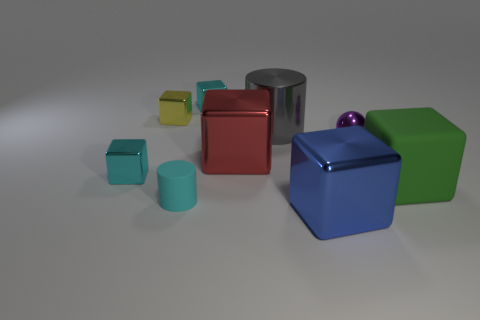How many cyan cubes are to the left of the green matte thing? There are two cyan cubes positioned to the left of the green matte cube. These cubes stand out with their light blue hue against the rest of the colorful objects in the scene. 